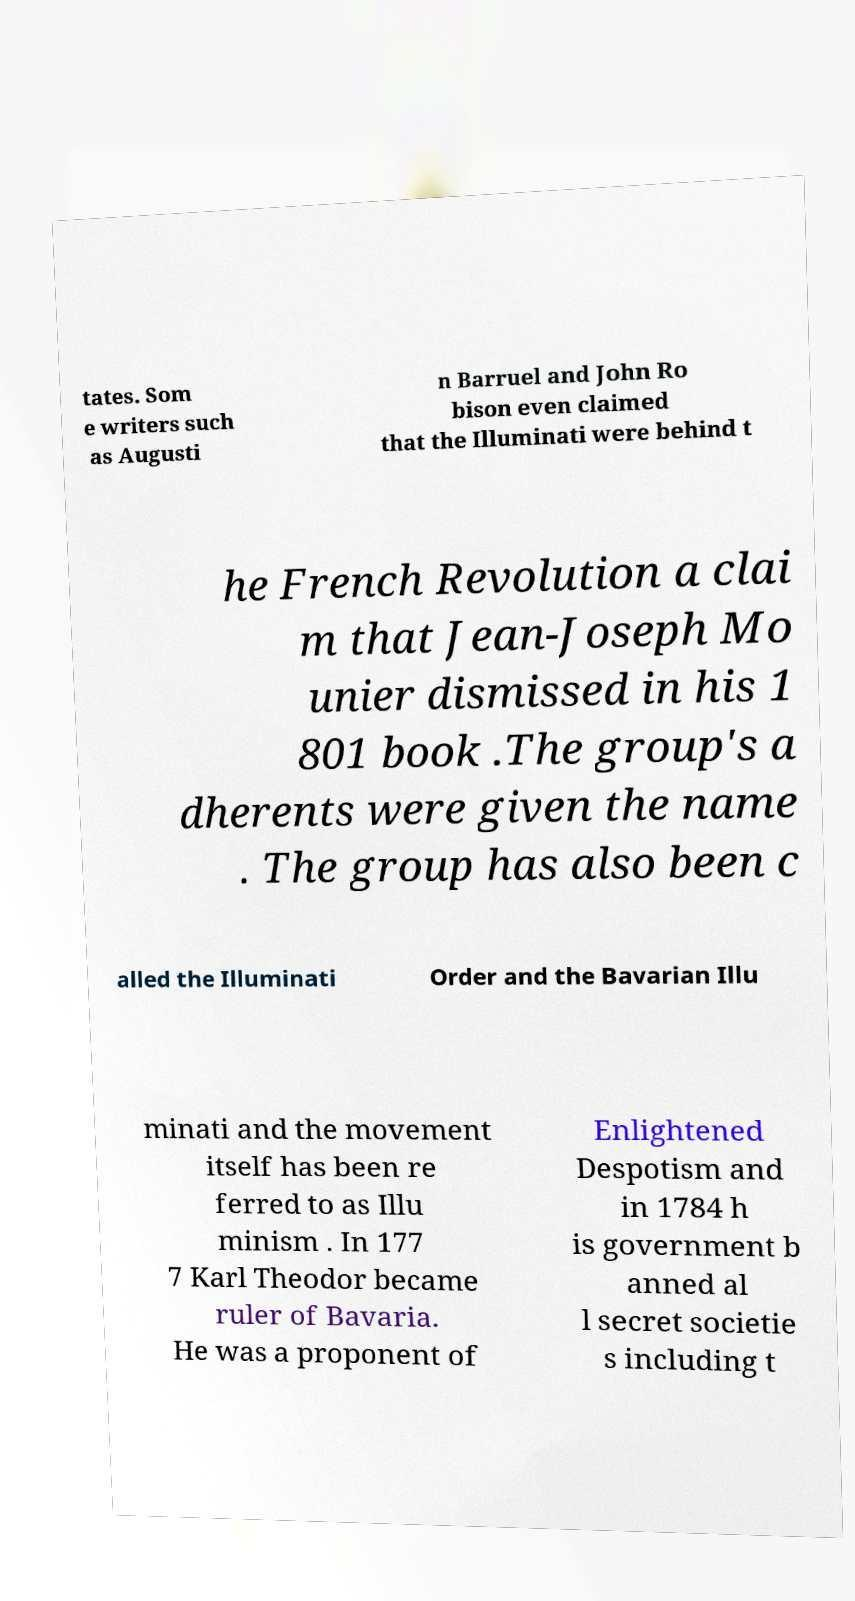There's text embedded in this image that I need extracted. Can you transcribe it verbatim? tates. Som e writers such as Augusti n Barruel and John Ro bison even claimed that the Illuminati were behind t he French Revolution a clai m that Jean-Joseph Mo unier dismissed in his 1 801 book .The group's a dherents were given the name . The group has also been c alled the Illuminati Order and the Bavarian Illu minati and the movement itself has been re ferred to as Illu minism . In 177 7 Karl Theodor became ruler of Bavaria. He was a proponent of Enlightened Despotism and in 1784 h is government b anned al l secret societie s including t 